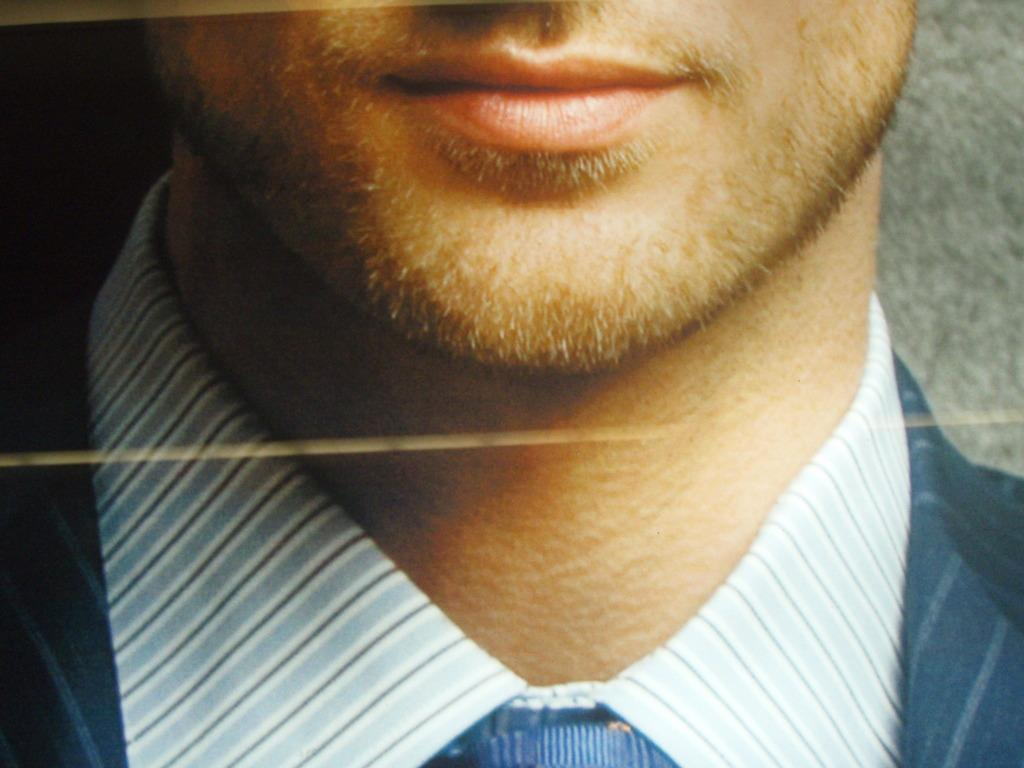Who is present in the image? There is a man in the image. What is the man wearing? The man is wearing a blue suit and a blue tie. How many trees can be seen in the image? There are no trees present in the image; it features a man wearing a blue suit and a blue tie. What type of thread is the man using to make a request in the image? There is no thread or request present in the image; it only shows a man wearing a blue suit and a blue tie. 